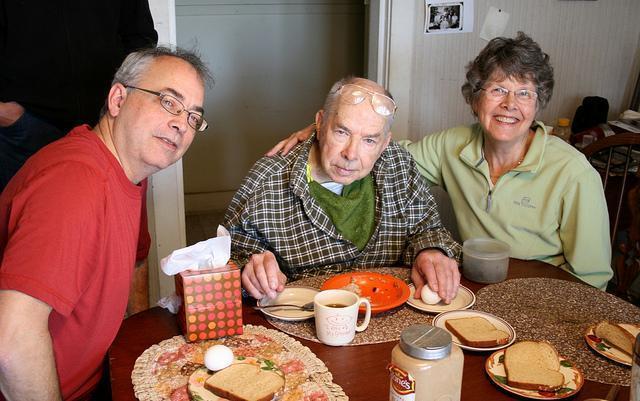How many people are in the picture?
Give a very brief answer. 3. How many people are there in the table?
Give a very brief answer. 3. How many people are wearing glasses?
Give a very brief answer. 3. How many mugs are there?
Give a very brief answer. 1. How many women in the room?
Give a very brief answer. 1. How many people are there?
Give a very brief answer. 4. How many sandwiches are there?
Give a very brief answer. 2. How many dining tables are there?
Give a very brief answer. 1. How many cars are on the crosswalk?
Give a very brief answer. 0. 